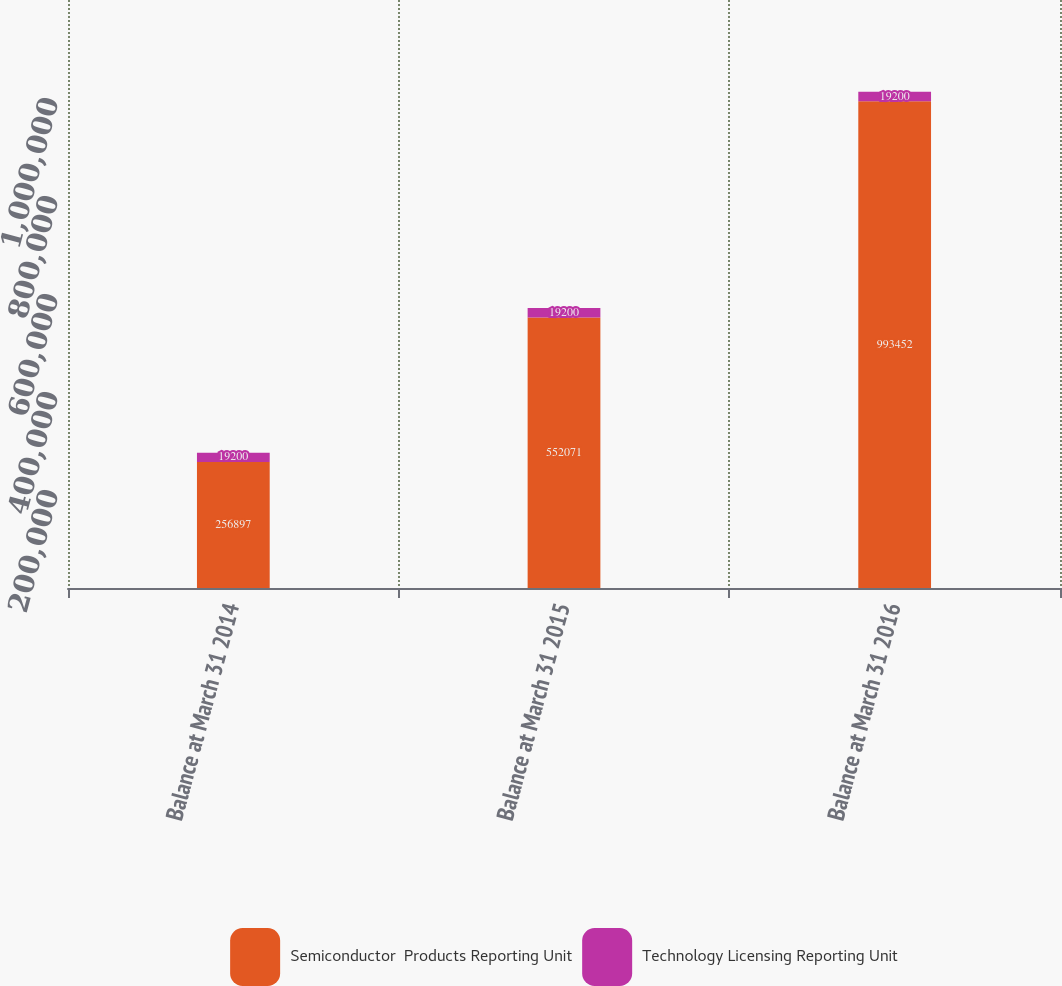<chart> <loc_0><loc_0><loc_500><loc_500><stacked_bar_chart><ecel><fcel>Balance at March 31 2014<fcel>Balance at March 31 2015<fcel>Balance at March 31 2016<nl><fcel>Semiconductor  Products Reporting Unit<fcel>256897<fcel>552071<fcel>993452<nl><fcel>Technology Licensing Reporting Unit<fcel>19200<fcel>19200<fcel>19200<nl></chart> 